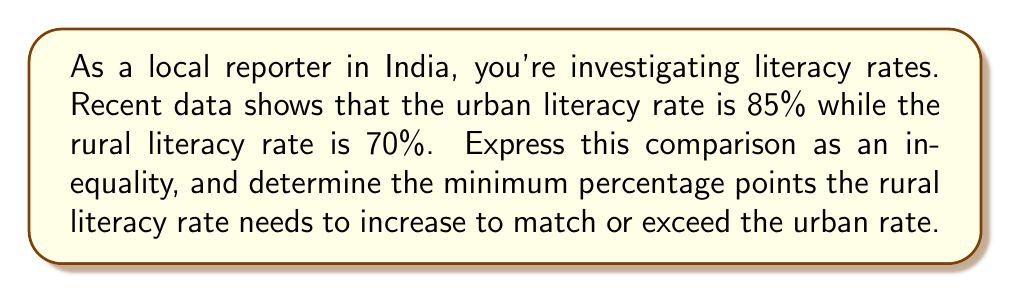Show me your answer to this math problem. Let's approach this step-by-step:

1) First, let's express the current situation as an inequality:
   Urban literacy rate > Rural literacy rate
   $85\% > 70\%$

2) To find how much the rural rate needs to increase, we need to solve:
   $70\% + x \geq 85\%$
   Where $x$ is the minimum increase needed.

3) Subtracting 70% from both sides:
   $x \geq 85\% - 70\%$

4) Simplifying:
   $x \geq 15\%$

5) Therefore, the rural literacy rate needs to increase by at least 15 percentage points to match or exceed the urban rate.

6) We can verify:
   $70\% + 15\% = 85\%$, which equals the urban rate.

7) Any increase greater than 15 percentage points would exceed the urban rate:
   $70\% + (15\% + \epsilon) > 85\%$, where $\epsilon$ is any positive value.
Answer: 15 percentage points 